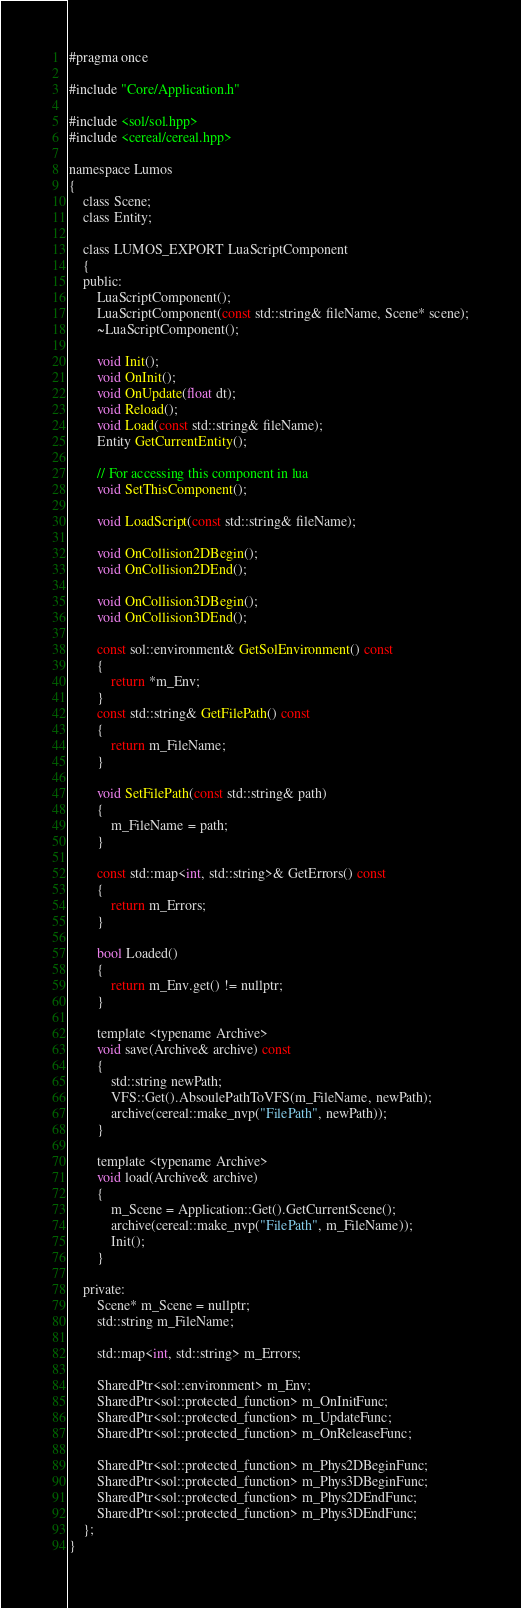Convert code to text. <code><loc_0><loc_0><loc_500><loc_500><_C_>#pragma once

#include "Core/Application.h"

#include <sol/sol.hpp>
#include <cereal/cereal.hpp>

namespace Lumos
{
    class Scene;
    class Entity;

    class LUMOS_EXPORT LuaScriptComponent
    {
    public:
        LuaScriptComponent();
        LuaScriptComponent(const std::string& fileName, Scene* scene);
        ~LuaScriptComponent();

        void Init();
        void OnInit();
        void OnUpdate(float dt);
        void Reload();
        void Load(const std::string& fileName);
        Entity GetCurrentEntity();

        // For accessing this component in lua
        void SetThisComponent();

        void LoadScript(const std::string& fileName);

        void OnCollision2DBegin();
        void OnCollision2DEnd();

        void OnCollision3DBegin();
        void OnCollision3DEnd();

        const sol::environment& GetSolEnvironment() const
        {
            return *m_Env;
        }
        const std::string& GetFilePath() const
        {
            return m_FileName;
        }

        void SetFilePath(const std::string& path)
        {
            m_FileName = path;
        }

        const std::map<int, std::string>& GetErrors() const
        {
            return m_Errors;
        }

        bool Loaded()
        {
            return m_Env.get() != nullptr;
        }

        template <typename Archive>
        void save(Archive& archive) const
        {
            std::string newPath;
            VFS::Get().AbsoulePathToVFS(m_FileName, newPath);
            archive(cereal::make_nvp("FilePath", newPath));
        }

        template <typename Archive>
        void load(Archive& archive)
        {
            m_Scene = Application::Get().GetCurrentScene();
            archive(cereal::make_nvp("FilePath", m_FileName));
            Init();
        }

    private:
        Scene* m_Scene = nullptr;
        std::string m_FileName;

        std::map<int, std::string> m_Errors;

        SharedPtr<sol::environment> m_Env;
        SharedPtr<sol::protected_function> m_OnInitFunc;
        SharedPtr<sol::protected_function> m_UpdateFunc;
        SharedPtr<sol::protected_function> m_OnReleaseFunc;

        SharedPtr<sol::protected_function> m_Phys2DBeginFunc;
        SharedPtr<sol::protected_function> m_Phys3DBeginFunc;
        SharedPtr<sol::protected_function> m_Phys2DEndFunc;
        SharedPtr<sol::protected_function> m_Phys3DEndFunc;
    };
}
</code> 